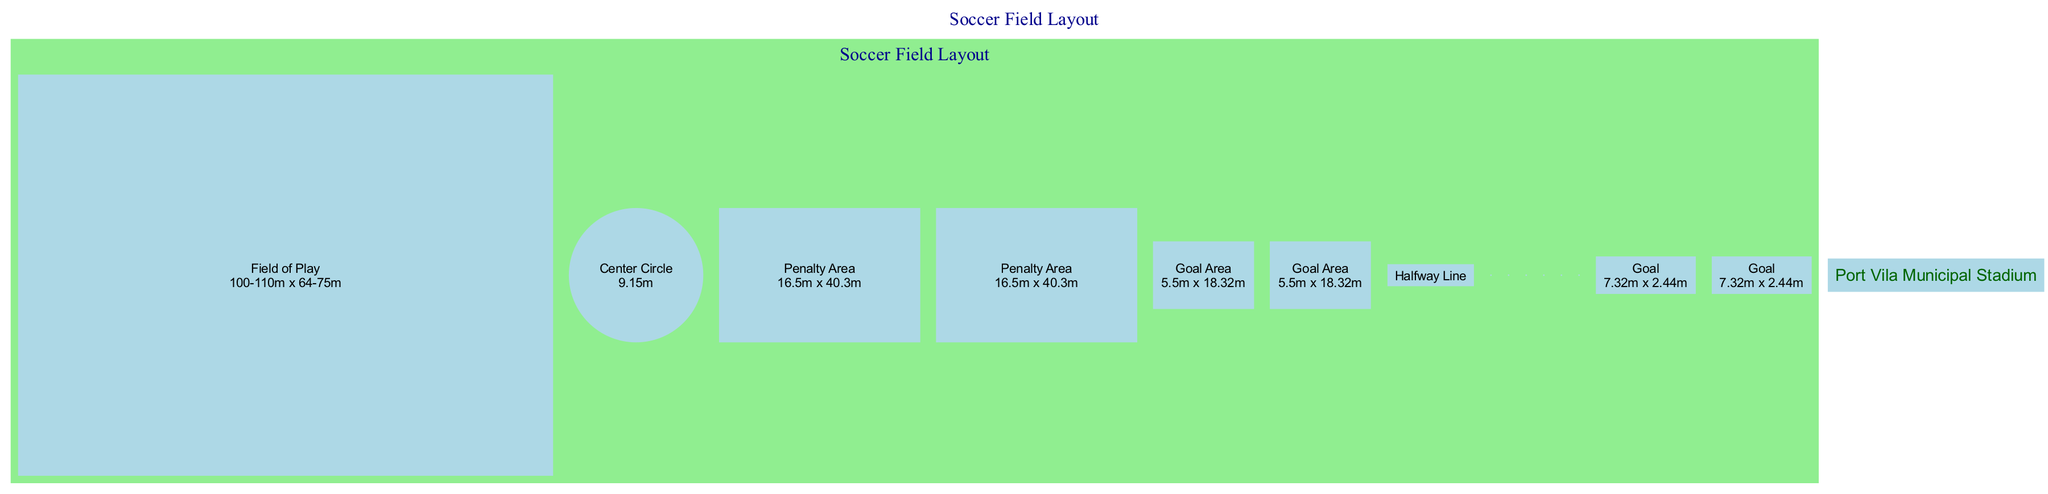What are the dimensions of the Field of Play? The Field of Play is labeled with dimensions ranging from 100-110 meters in length and 64-75 meters in width. The answer can be directly found in the diagram under the "Field of Play" node.
Answer: 100-110m x 64-75m What is the diameter of the Center Circle? The diagram specifies the diameter of the Center Circle explicitly next to its label. This is a straightforward retrieval of information presented in the diagram.
Answer: 9.15m How far is the Penalty Spot from the goal line? The distance of the Penalty Spot is stated in the diagram as being 11 meters from the goal line. This figure is found near the Penalty Spot label within the diagram.
Answer: 11m How many Corner Arcs are shown in the diagram? The diagram includes four representations of Corner Arcs, each labeled and placed at different corners of the field. By counting these distinct nodes, the answer emerges.
Answer: 4 What is the size of the Goal Area? The Goal Area is described in the diagram with specific dimensions. This information is extracted directly by identifying the Goal Area's label and its corresponding dimensions listed in the diagram.
Answer: 5.5m x 18.32m Which element is centered in the middle of the field layout? By reviewing the positions of each element in the diagram, the Center Circle is positioned centrally, directly in the middle of the field layout, making it the reference point.
Answer: Center Circle What is the total length of the Goal? The diagram provides the dimensions of the Goal, clearly labeled alongside its specifications. This allows for the straightforward identification of the Goal's length as described in the element.
Answer: 7.32m Describe the relationship between the Penalty Area and the Goal. The Penalty Area is positioned directly in front of the Goal as indicated in the diagram, establishing a functional relationship since the Penalty Spot is also related to the goal during gameplay.
Answer: In front of the Goal What distinguishes the Penalty Area from the Goal Area in terms of dimensions? The dimensions of both areas are stated in the diagram; by comparing the given measurements—40.3m for Penalty Area and 18.32m for Goal Area—one can identify their differences.
Answer: Different dimensions 